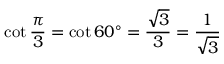Convert formula to latex. <formula><loc_0><loc_0><loc_500><loc_500>\cot { \frac { \pi } { 3 } } = \cot 6 0 ^ { \circ } = { \frac { \sqrt { 3 } } { 3 } } = { \frac { 1 } { \sqrt { 3 } } }</formula> 